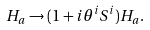Convert formula to latex. <formula><loc_0><loc_0><loc_500><loc_500>H _ { a } \to ( 1 + i \theta ^ { i } S ^ { i } ) H _ { a } .</formula> 